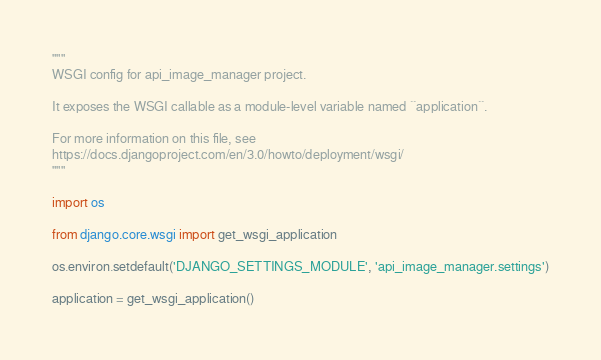<code> <loc_0><loc_0><loc_500><loc_500><_Python_>"""
WSGI config for api_image_manager project.

It exposes the WSGI callable as a module-level variable named ``application``.

For more information on this file, see
https://docs.djangoproject.com/en/3.0/howto/deployment/wsgi/
"""

import os

from django.core.wsgi import get_wsgi_application

os.environ.setdefault('DJANGO_SETTINGS_MODULE', 'api_image_manager.settings')

application = get_wsgi_application()
</code> 